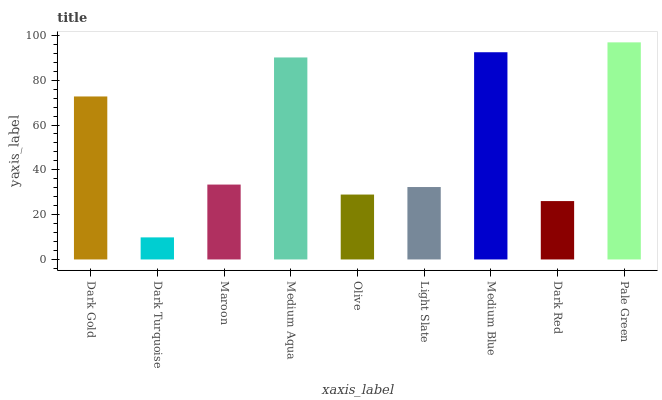Is Dark Turquoise the minimum?
Answer yes or no. Yes. Is Pale Green the maximum?
Answer yes or no. Yes. Is Maroon the minimum?
Answer yes or no. No. Is Maroon the maximum?
Answer yes or no. No. Is Maroon greater than Dark Turquoise?
Answer yes or no. Yes. Is Dark Turquoise less than Maroon?
Answer yes or no. Yes. Is Dark Turquoise greater than Maroon?
Answer yes or no. No. Is Maroon less than Dark Turquoise?
Answer yes or no. No. Is Maroon the high median?
Answer yes or no. Yes. Is Maroon the low median?
Answer yes or no. Yes. Is Dark Gold the high median?
Answer yes or no. No. Is Medium Blue the low median?
Answer yes or no. No. 